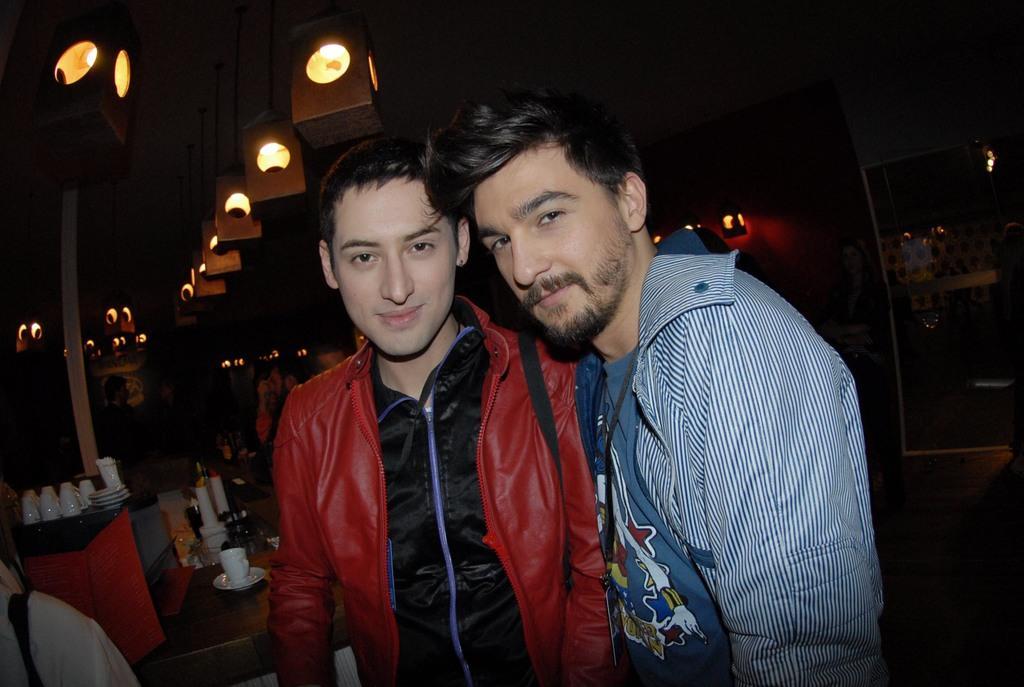Please provide a concise description of this image. In this image I can see two persons standing, the person at right is wearing blue color dress and the person at left is wearing red jacket and black shirt, background I can see few plants and glasses on the table and I can see few lights. 